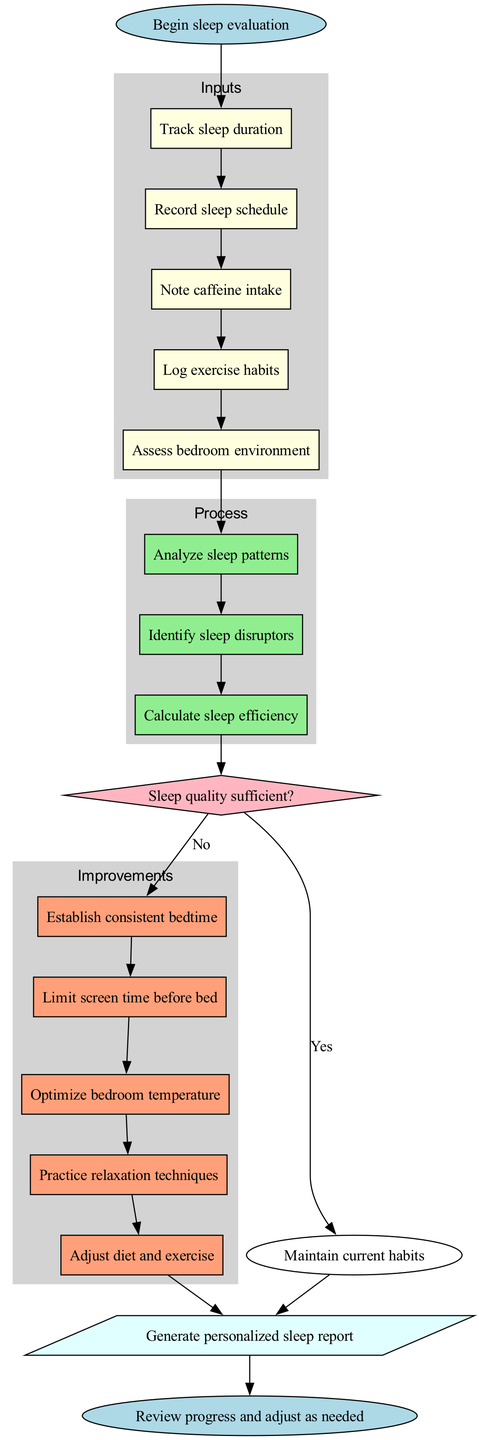What is the first input in the evaluation process? The diagram lists the first input node as "Track sleep duration". It is the starting point for inputs leading into the process.
Answer: Track sleep duration How many improvements are suggested after evaluating sleep quality? The diagram shows a total of five improvement steps listed under the Improvements section.
Answer: Five What happens if sleep quality is sufficient? The "Yes" path from the decision node leads to "Maintain current habits," indicating that if sleep quality is sufficient, the current habits should be continued.
Answer: Maintain current habits What process follows after all inputs have been recorded? Following the inputs, the flow chart indicates that the next step is to "Analyze sleep patterns," which is the first process node.
Answer: Analyze sleep patterns Which decision node assesses sleep quality? The decision node labeled "Sleep quality sufficient?" directly assesses whether sleep quality is adequate and leads to subsequent actions based on the answer.
Answer: Sleep quality sufficient? What is the last step of the flow chart? The final step in the diagram is labeled "Review progress and adjust as needed," which serves as the closure of the evaluation process.
Answer: Review progress and adjust as needed How many process steps are included in total? There are three process steps listed: "Analyze sleep patterns," "Identify sleep disruptors," and "Calculate sleep efficiency," making a total of three processes.
Answer: Three Which improvement technique focuses on pre-sleep habits? The improvement node "Limit screen time before bed" targets pre-sleep habits aimed at enhancing overall sleep quality.
Answer: Limit screen time before bed What connects the input nodes to the process nodes? Each input node is sequentially connected by edges leading directly to the process nodes, allowing for a smooth transition from input to process.
Answer: Edges 